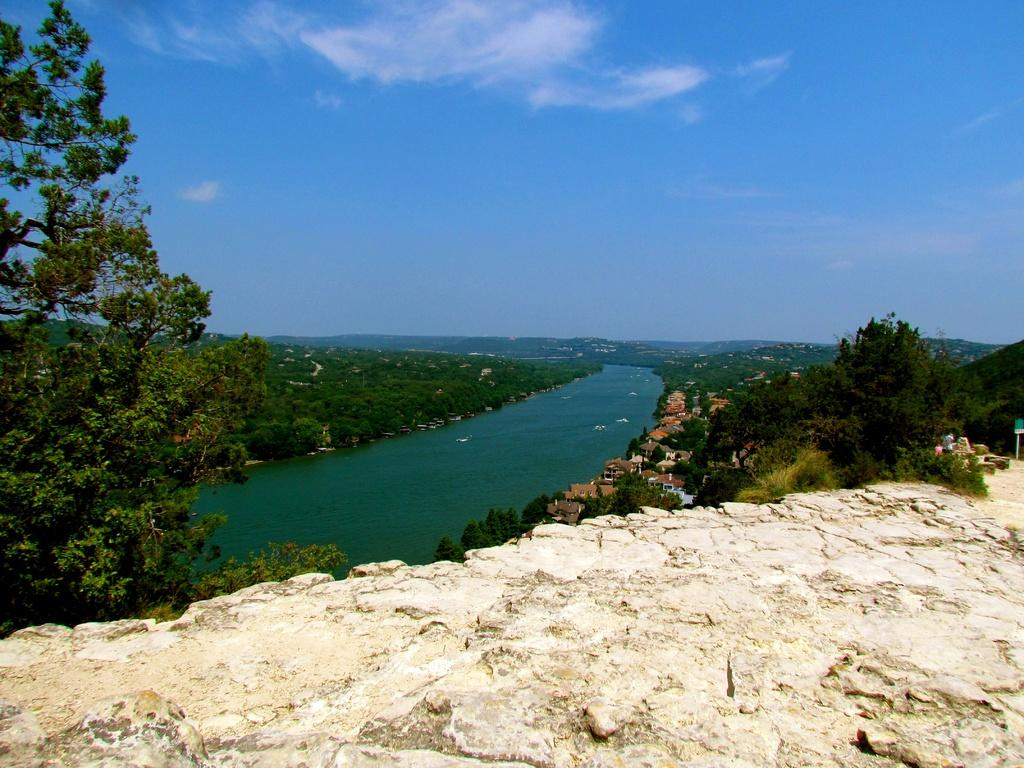What is the main feature of the image? There is a huge stone in the image. What surrounds the stone? There is a water surface around the stone. What type of vegetation can be seen in the image? Trees are present in the image. Are there any man-made structures visible? Houses are visible in the image. How much honey is being produced by the bees near the stone in the image? There are no bees or indication of honey production in the image. 